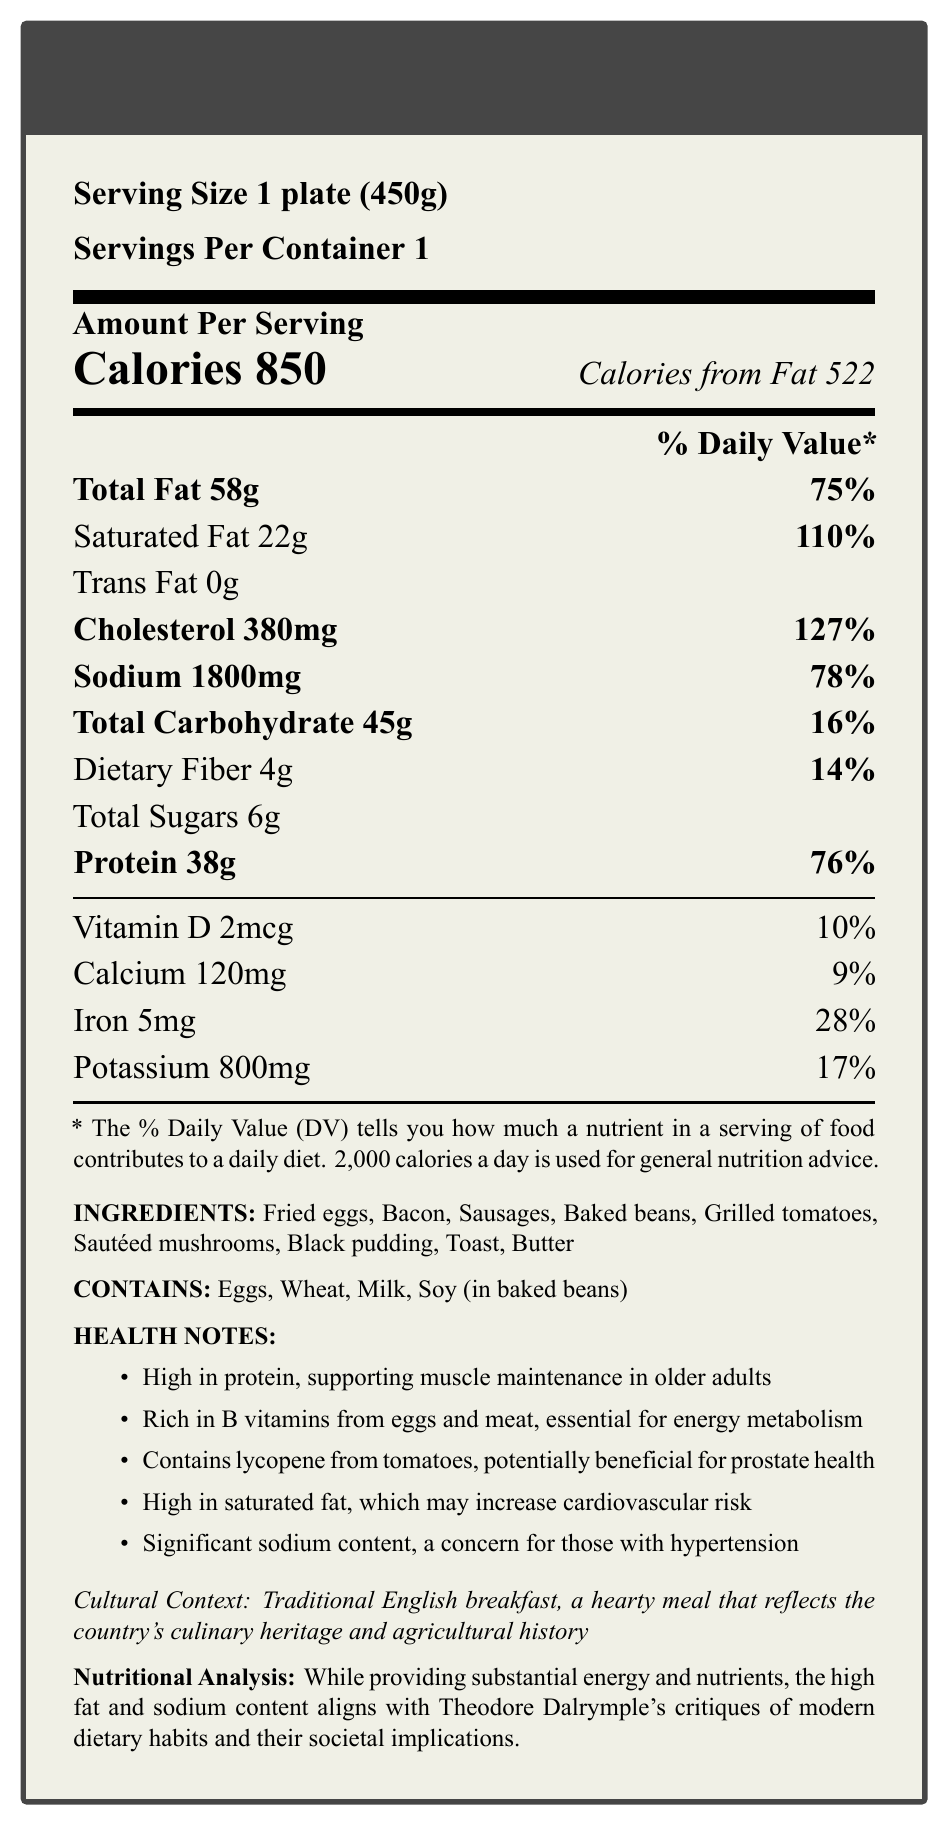what is the serving size? The serving size is explicitly stated as 1 plate (450g).
Answer: 1 plate (450g) how many calories are in a serving of the traditional English breakfast? The document states that there are 850 calories per serving.
Answer: 850 calories what percentage of the daily value of cholesterol does one serving contain? The document specifies that the cholesterol content per serving is 380mg, which is 127% of the daily value.
Answer: 127% what are the main ingredients listed for the traditional English breakfast? The ingredients section lists these items.
Answer: Fried eggs, Bacon, Sausages, Baked beans, Grilled tomatoes, Sautéed mushrooms, Black pudding, Toast, Butter what does the document mention about the relationship between high sodium content and health? The health notes mention that the high sodium content is a concern for those with hypertension.
Answer: Significant sodium content, a concern for those with hypertension how much protein does one serving contain? The document specifies that one serving contains 38g of protein.
Answer: 38g which of these is NOT an allergen listed for the traditional English breakfast? A. Eggs B. Milk C. Nuts D. Wheat All listed allergens in the document are Eggs, Wheat, Milk, and Soy (in baked beans). Nuts are not listed.
Answer: C. Nuts what is the main critique mentioned in the nutritional analysis section? A. Low protein content B. High fat and sodium content C. Lack of vitamins D. Low calorie content The nutritional analysis highlights the high fat and sodium content as a critique aligned with Theodore Dalrymple's views on modern dietary habits.
Answer: B. High fat and sodium content true or false: the traditional English breakfast contains trans fat. The document explicitly states that the trans fat content is 0g.
Answer: False summarize the main idea of the document. The document provides comprehensive nutritional information, ingredients, and potential health impacts of a traditional English breakfast, noting its high fat and protein content and cultural significance.
Answer: The document is a nutrition facts label for a traditional English breakfast, detailing the serving size, calories, nutrients, ingredients, allergens, and health notes. It highlights the high fat and protein content, along with specific health considerations and a cultural context explanation. how many grams of dietary fiber are in one serving? The dietary fiber content is specified as 4g per serving.
Answer: 4g can you determine the exact potassium source from the ingredients list? The document provides the amount of potassium (800mg) but does not specify which ingredient(s) it comes from.
Answer: Not enough information what is the primary source of calories in the traditional English breakfast? The document notes that 522 out of 850 total calories come from fat, making it the primary source of calories.
Answer: Fat 